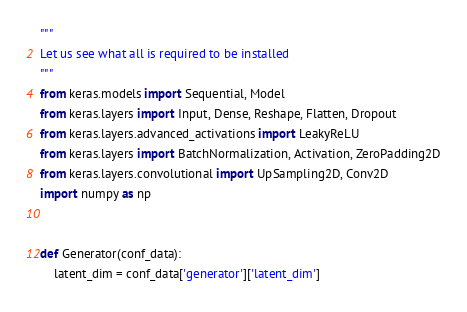Convert code to text. <code><loc_0><loc_0><loc_500><loc_500><_Python_>"""
Let us see what all is required to be installed
"""
from keras.models import Sequential, Model
from keras.layers import Input, Dense, Reshape, Flatten, Dropout
from keras.layers.advanced_activations import LeakyReLU
from keras.layers import BatchNormalization, Activation, ZeroPadding2D
from keras.layers.convolutional import UpSampling2D, Conv2D
import numpy as np


def Generator(conf_data):
	latent_dim = conf_data['generator']['latent_dim']</code> 